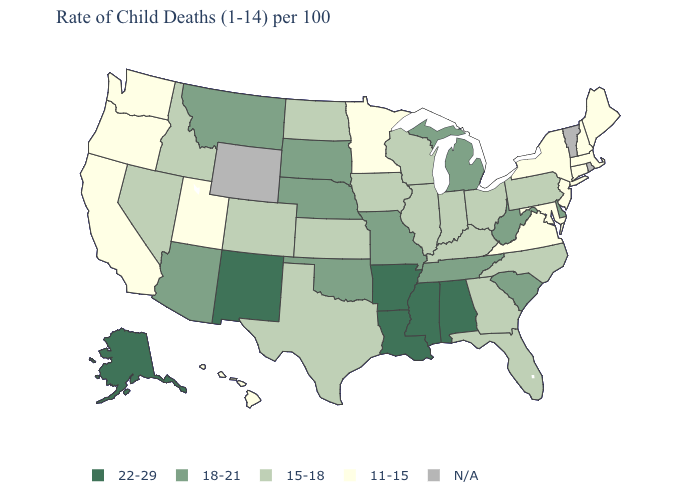What is the value of Kentucky?
Keep it brief. 15-18. Name the states that have a value in the range 11-15?
Concise answer only. California, Connecticut, Hawaii, Maine, Maryland, Massachusetts, Minnesota, New Hampshire, New Jersey, New York, Oregon, Utah, Virginia, Washington. Does the map have missing data?
Quick response, please. Yes. What is the value of Oregon?
Short answer required. 11-15. Name the states that have a value in the range 11-15?
Short answer required. California, Connecticut, Hawaii, Maine, Maryland, Massachusetts, Minnesota, New Hampshire, New Jersey, New York, Oregon, Utah, Virginia, Washington. What is the value of South Dakota?
Give a very brief answer. 18-21. Name the states that have a value in the range 15-18?
Be succinct. Colorado, Florida, Georgia, Idaho, Illinois, Indiana, Iowa, Kansas, Kentucky, Nevada, North Carolina, North Dakota, Ohio, Pennsylvania, Texas, Wisconsin. What is the lowest value in the West?
Write a very short answer. 11-15. What is the value of South Carolina?
Write a very short answer. 18-21. Name the states that have a value in the range 18-21?
Give a very brief answer. Arizona, Delaware, Michigan, Missouri, Montana, Nebraska, Oklahoma, South Carolina, South Dakota, Tennessee, West Virginia. Name the states that have a value in the range 22-29?
Quick response, please. Alabama, Alaska, Arkansas, Louisiana, Mississippi, New Mexico. Among the states that border Georgia , which have the highest value?
Keep it brief. Alabama. 